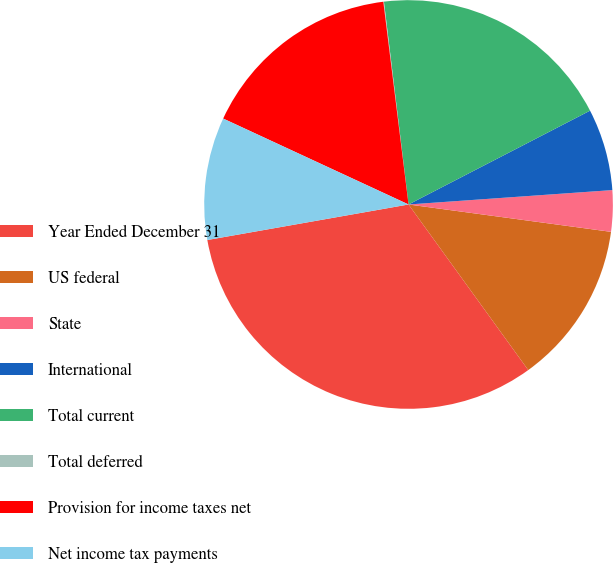<chart> <loc_0><loc_0><loc_500><loc_500><pie_chart><fcel>Year Ended December 31<fcel>US federal<fcel>State<fcel>International<fcel>Total current<fcel>Total deferred<fcel>Provision for income taxes net<fcel>Net income tax payments<nl><fcel>32.18%<fcel>12.9%<fcel>3.26%<fcel>6.47%<fcel>19.33%<fcel>0.05%<fcel>16.12%<fcel>9.69%<nl></chart> 